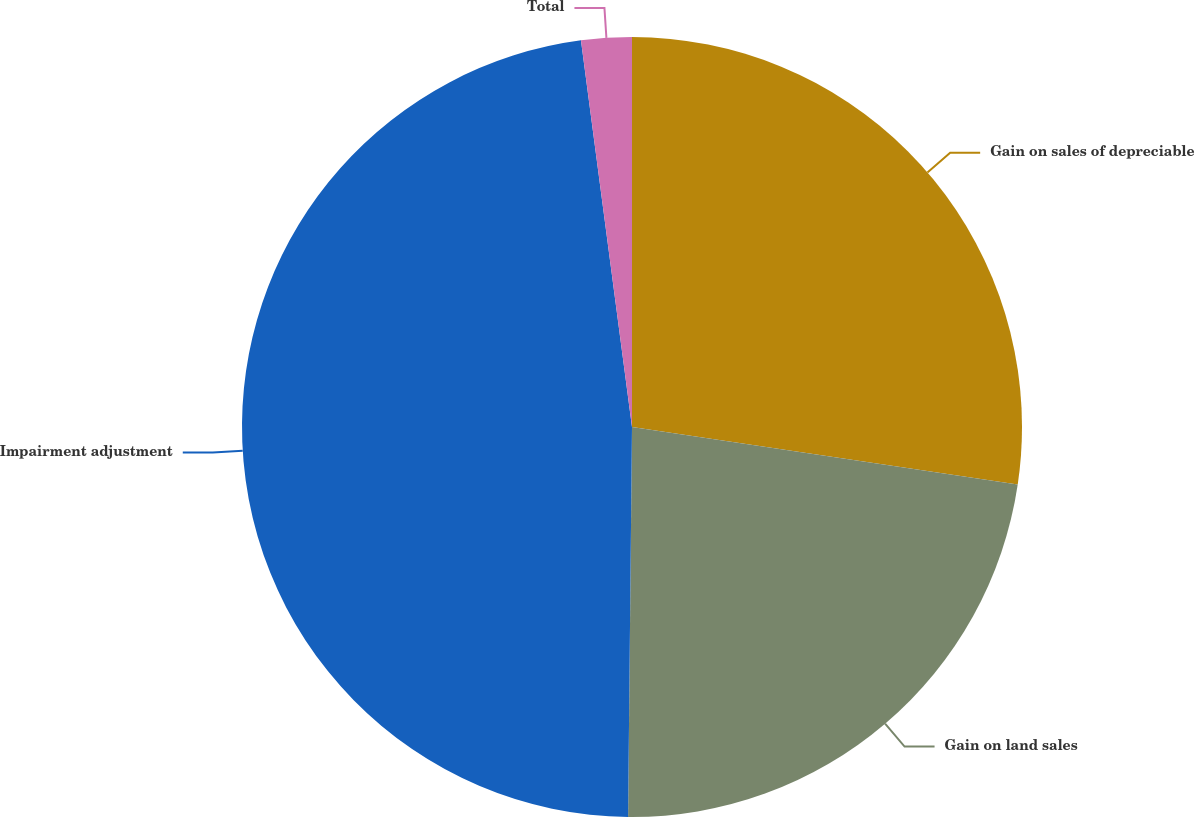<chart> <loc_0><loc_0><loc_500><loc_500><pie_chart><fcel>Gain on sales of depreciable<fcel>Gain on land sales<fcel>Impairment adjustment<fcel>Total<nl><fcel>27.36%<fcel>22.8%<fcel>47.75%<fcel>2.09%<nl></chart> 